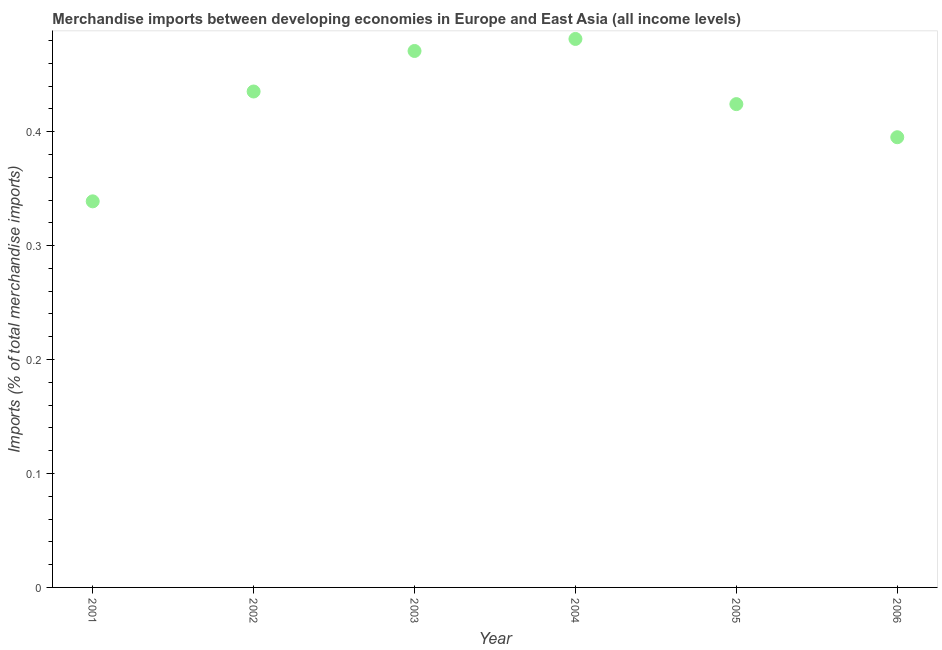What is the merchandise imports in 2004?
Give a very brief answer. 0.48. Across all years, what is the maximum merchandise imports?
Make the answer very short. 0.48. Across all years, what is the minimum merchandise imports?
Provide a succinct answer. 0.34. In which year was the merchandise imports maximum?
Ensure brevity in your answer.  2004. What is the sum of the merchandise imports?
Give a very brief answer. 2.55. What is the difference between the merchandise imports in 2003 and 2005?
Offer a very short reply. 0.05. What is the average merchandise imports per year?
Make the answer very short. 0.42. What is the median merchandise imports?
Offer a very short reply. 0.43. What is the ratio of the merchandise imports in 2001 to that in 2005?
Your response must be concise. 0.8. Is the difference between the merchandise imports in 2001 and 2005 greater than the difference between any two years?
Keep it short and to the point. No. What is the difference between the highest and the second highest merchandise imports?
Offer a very short reply. 0.01. Is the sum of the merchandise imports in 2003 and 2005 greater than the maximum merchandise imports across all years?
Your answer should be very brief. Yes. What is the difference between the highest and the lowest merchandise imports?
Offer a terse response. 0.14. How many dotlines are there?
Your response must be concise. 1. What is the difference between two consecutive major ticks on the Y-axis?
Your response must be concise. 0.1. Does the graph contain grids?
Keep it short and to the point. No. What is the title of the graph?
Offer a very short reply. Merchandise imports between developing economies in Europe and East Asia (all income levels). What is the label or title of the X-axis?
Offer a very short reply. Year. What is the label or title of the Y-axis?
Offer a very short reply. Imports (% of total merchandise imports). What is the Imports (% of total merchandise imports) in 2001?
Provide a short and direct response. 0.34. What is the Imports (% of total merchandise imports) in 2002?
Provide a succinct answer. 0.44. What is the Imports (% of total merchandise imports) in 2003?
Your answer should be compact. 0.47. What is the Imports (% of total merchandise imports) in 2004?
Ensure brevity in your answer.  0.48. What is the Imports (% of total merchandise imports) in 2005?
Offer a very short reply. 0.42. What is the Imports (% of total merchandise imports) in 2006?
Your response must be concise. 0.4. What is the difference between the Imports (% of total merchandise imports) in 2001 and 2002?
Your response must be concise. -0.1. What is the difference between the Imports (% of total merchandise imports) in 2001 and 2003?
Provide a succinct answer. -0.13. What is the difference between the Imports (% of total merchandise imports) in 2001 and 2004?
Offer a terse response. -0.14. What is the difference between the Imports (% of total merchandise imports) in 2001 and 2005?
Your response must be concise. -0.09. What is the difference between the Imports (% of total merchandise imports) in 2001 and 2006?
Provide a short and direct response. -0.06. What is the difference between the Imports (% of total merchandise imports) in 2002 and 2003?
Ensure brevity in your answer.  -0.04. What is the difference between the Imports (% of total merchandise imports) in 2002 and 2004?
Keep it short and to the point. -0.05. What is the difference between the Imports (% of total merchandise imports) in 2002 and 2005?
Offer a very short reply. 0.01. What is the difference between the Imports (% of total merchandise imports) in 2002 and 2006?
Give a very brief answer. 0.04. What is the difference between the Imports (% of total merchandise imports) in 2003 and 2004?
Give a very brief answer. -0.01. What is the difference between the Imports (% of total merchandise imports) in 2003 and 2005?
Offer a very short reply. 0.05. What is the difference between the Imports (% of total merchandise imports) in 2003 and 2006?
Keep it short and to the point. 0.08. What is the difference between the Imports (% of total merchandise imports) in 2004 and 2005?
Make the answer very short. 0.06. What is the difference between the Imports (% of total merchandise imports) in 2004 and 2006?
Your answer should be compact. 0.09. What is the difference between the Imports (% of total merchandise imports) in 2005 and 2006?
Offer a terse response. 0.03. What is the ratio of the Imports (% of total merchandise imports) in 2001 to that in 2002?
Your answer should be very brief. 0.78. What is the ratio of the Imports (% of total merchandise imports) in 2001 to that in 2003?
Offer a terse response. 0.72. What is the ratio of the Imports (% of total merchandise imports) in 2001 to that in 2004?
Make the answer very short. 0.7. What is the ratio of the Imports (% of total merchandise imports) in 2001 to that in 2005?
Your answer should be very brief. 0.8. What is the ratio of the Imports (% of total merchandise imports) in 2001 to that in 2006?
Offer a terse response. 0.86. What is the ratio of the Imports (% of total merchandise imports) in 2002 to that in 2003?
Ensure brevity in your answer.  0.92. What is the ratio of the Imports (% of total merchandise imports) in 2002 to that in 2004?
Provide a succinct answer. 0.9. What is the ratio of the Imports (% of total merchandise imports) in 2002 to that in 2006?
Provide a short and direct response. 1.1. What is the ratio of the Imports (% of total merchandise imports) in 2003 to that in 2005?
Provide a short and direct response. 1.11. What is the ratio of the Imports (% of total merchandise imports) in 2003 to that in 2006?
Keep it short and to the point. 1.19. What is the ratio of the Imports (% of total merchandise imports) in 2004 to that in 2005?
Your answer should be compact. 1.14. What is the ratio of the Imports (% of total merchandise imports) in 2004 to that in 2006?
Keep it short and to the point. 1.22. What is the ratio of the Imports (% of total merchandise imports) in 2005 to that in 2006?
Offer a terse response. 1.07. 